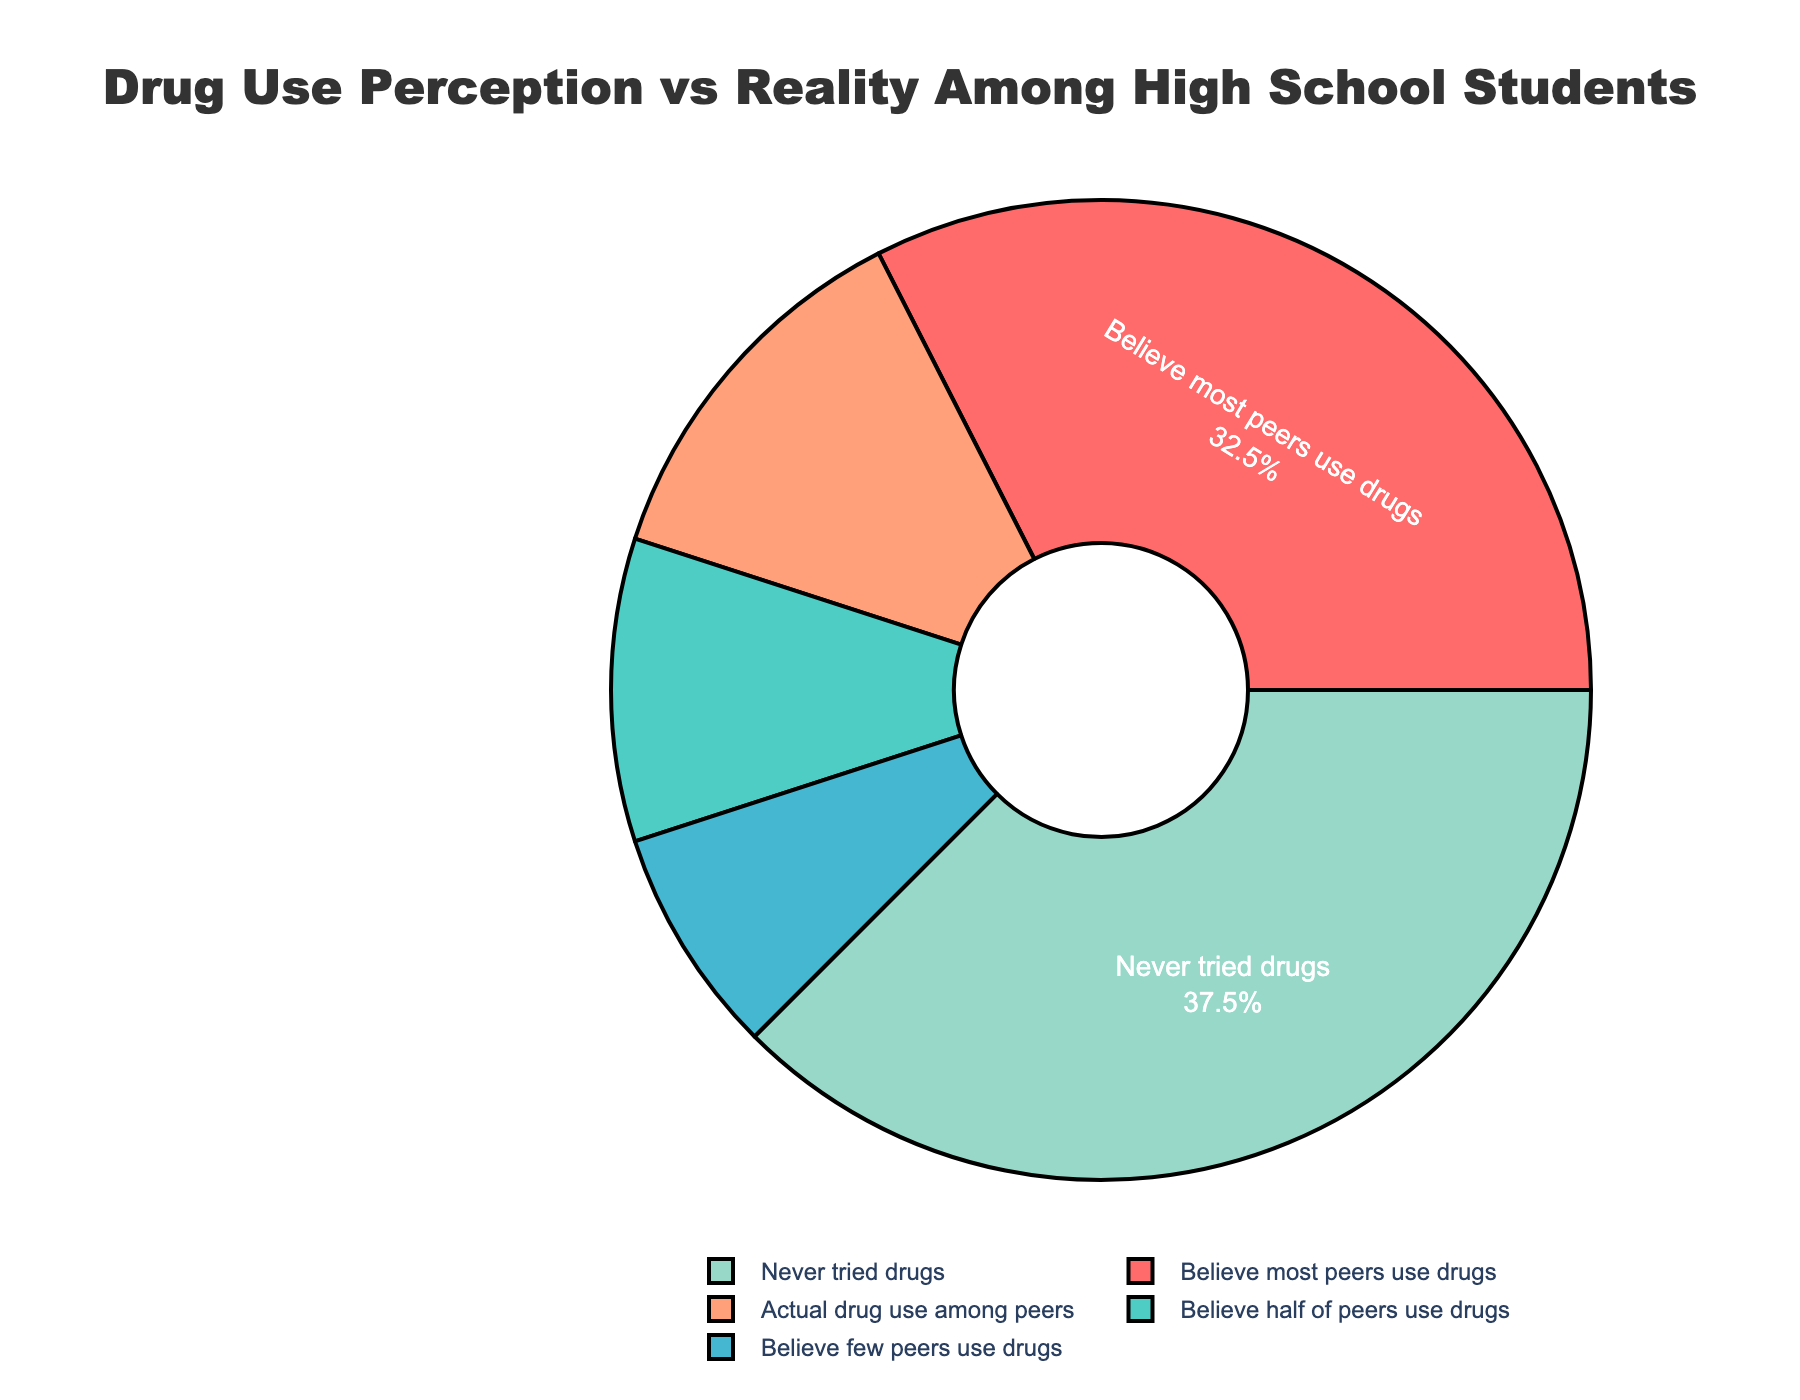What's the percentage of high school students who actually use drugs? Look at the segment labeled "Actual drug use among peers" and check its associated percentage.
Answer: 25% Which perception about peers' drug use is most common among high school students? Check the segment with the largest percentage labeled under "Believe most peers use drugs" which represents the most common perception.
Answer: Believe most peers use drugs How many percentage points higher is the perception of "Believe most peers use drugs" compared to the actual drug use among peers? Subtract the percentage of "Actual drug use among peers" from "Believe most peers use drugs" (65% - 25%).
Answer: 40 percentage points What's the total percentage of high school students who believe that few or half of their peers use drugs? Add the percentage of "Believe few peers use drugs" and "Believe half of peers use drugs" (15% + 20%).
Answer: 35% What is the difference in percentage between students who believe all/half/few peers use drugs and those who never tried drugs? Sum up the percentages of "Believe most peers use drugs," "Believe half of peers use drugs," and "Believe few peers use drugs," then subtract this from the percentage of "Never tried drugs" (100% - 35% - 75%).
Answer: 65 percentage points Which segment on the pie chart is the largest? Identify the segment with the largest percentage which has the label "Never tried drugs".
Answer: Never tried drugs Is the perception of drug use among peers generally higher or lower than the actual drug use? Compare the sum of the perceptions (believe most, half, and few) to the actual use percentage. The perception sum (65% + 20% + 15% = 100%) is higher than the actual use percentage (25%).
Answer: Higher 